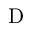<formula> <loc_0><loc_0><loc_500><loc_500>D</formula> 